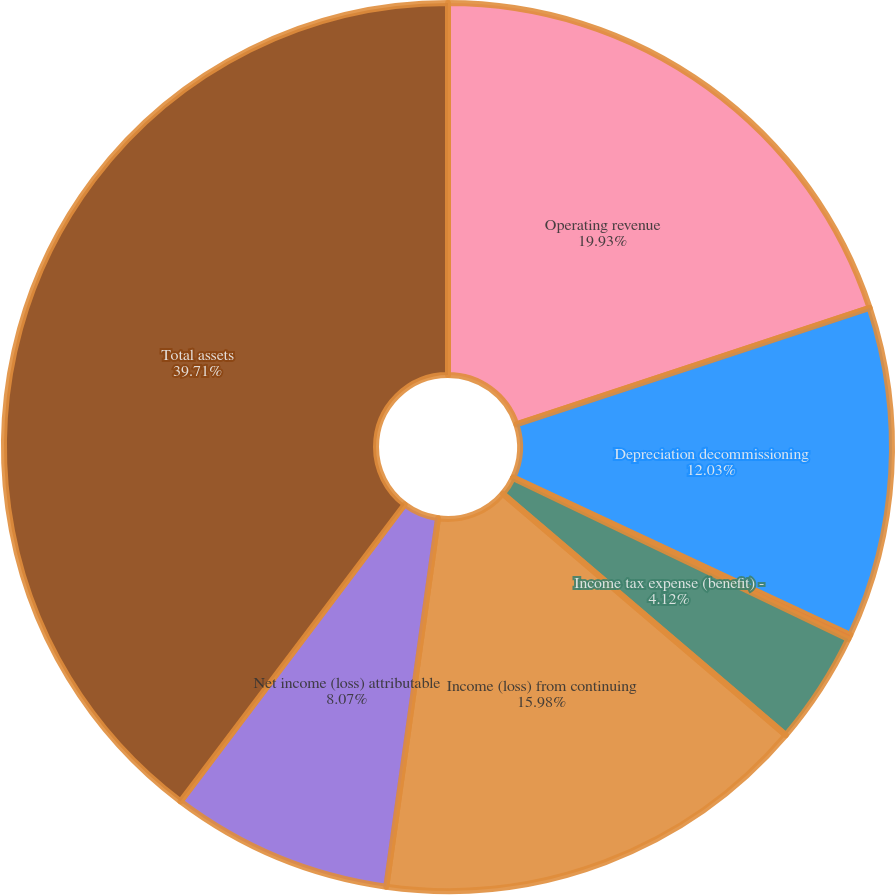<chart> <loc_0><loc_0><loc_500><loc_500><pie_chart><fcel>Operating revenue<fcel>Depreciation decommissioning<fcel>Interest and dividend income<fcel>Income tax expense (benefit) -<fcel>Income (loss) from continuing<fcel>Net income (loss) attributable<fcel>Total assets<nl><fcel>19.93%<fcel>12.03%<fcel>0.16%<fcel>4.12%<fcel>15.98%<fcel>8.07%<fcel>39.71%<nl></chart> 